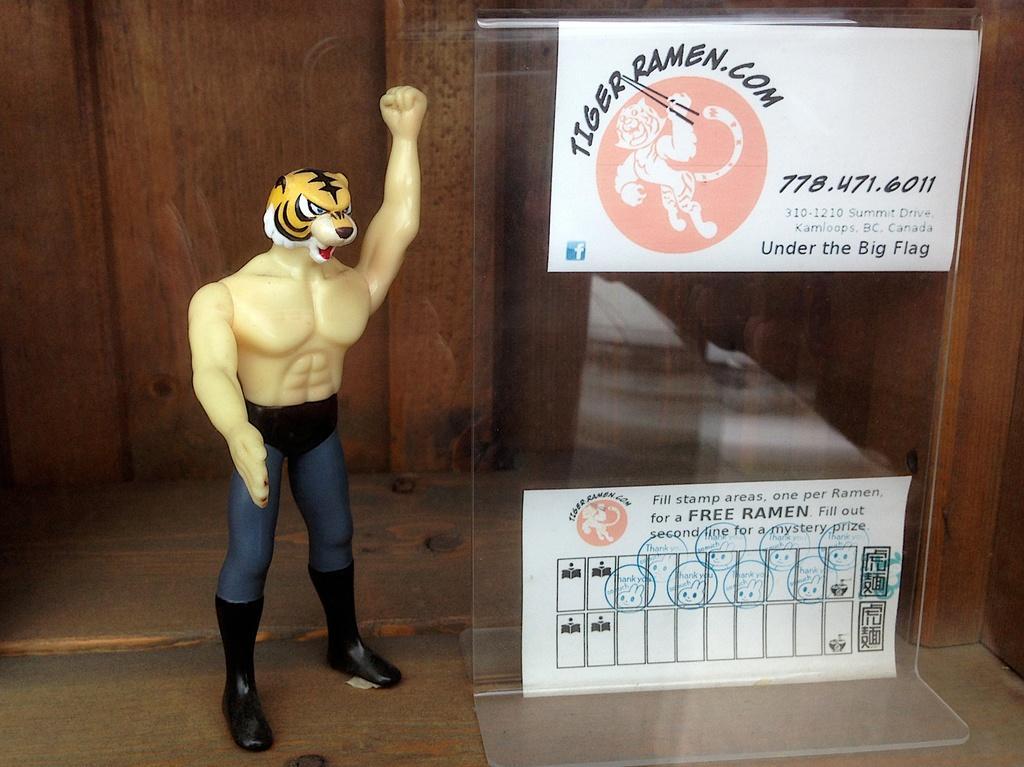Please provide a concise description of this image. In this picture, we see the figurine. Beside that, we see a glass board on which some posters in white color with some text written are pasted. In the background, we see the wooden wall which is brown in color. 